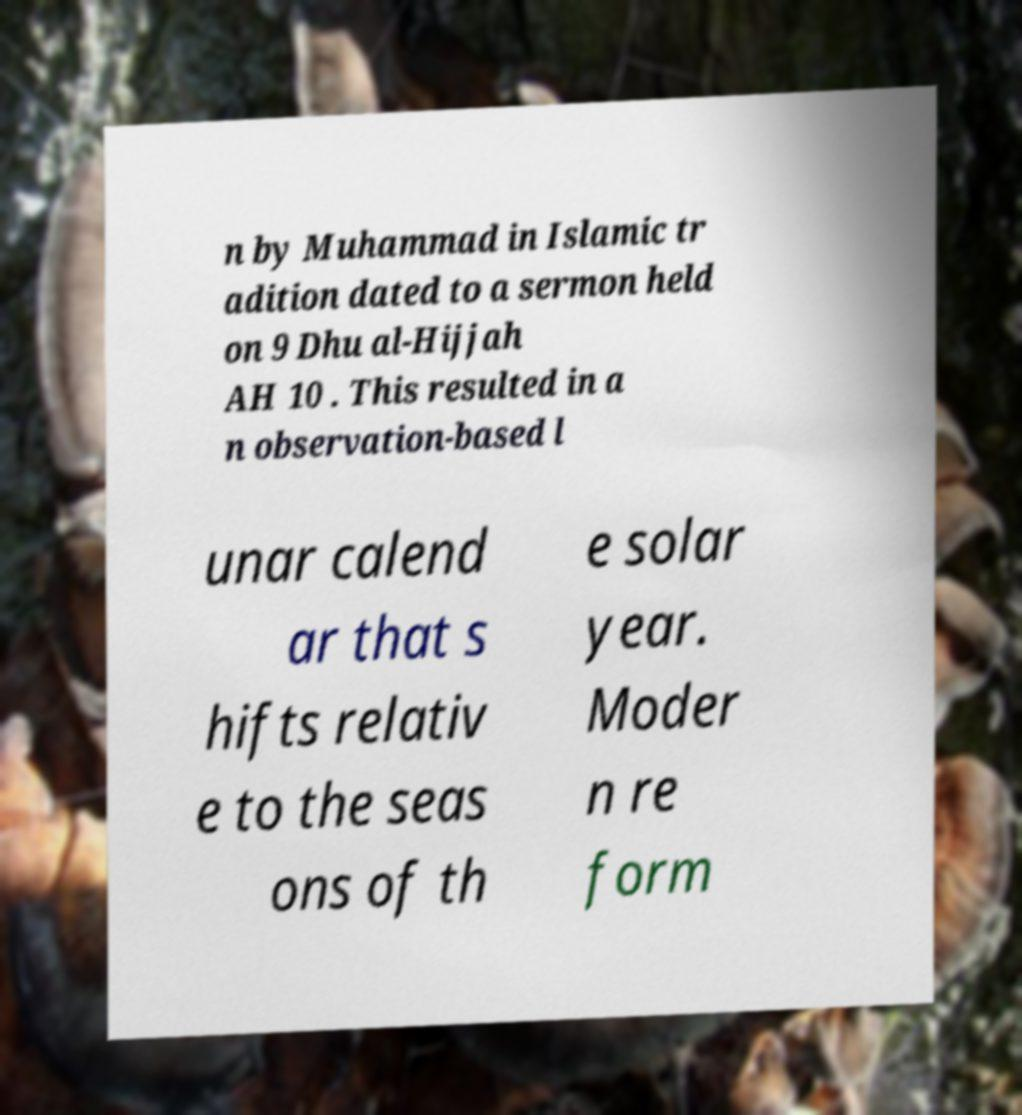There's text embedded in this image that I need extracted. Can you transcribe it verbatim? n by Muhammad in Islamic tr adition dated to a sermon held on 9 Dhu al-Hijjah AH 10 . This resulted in a n observation-based l unar calend ar that s hifts relativ e to the seas ons of th e solar year. Moder n re form 